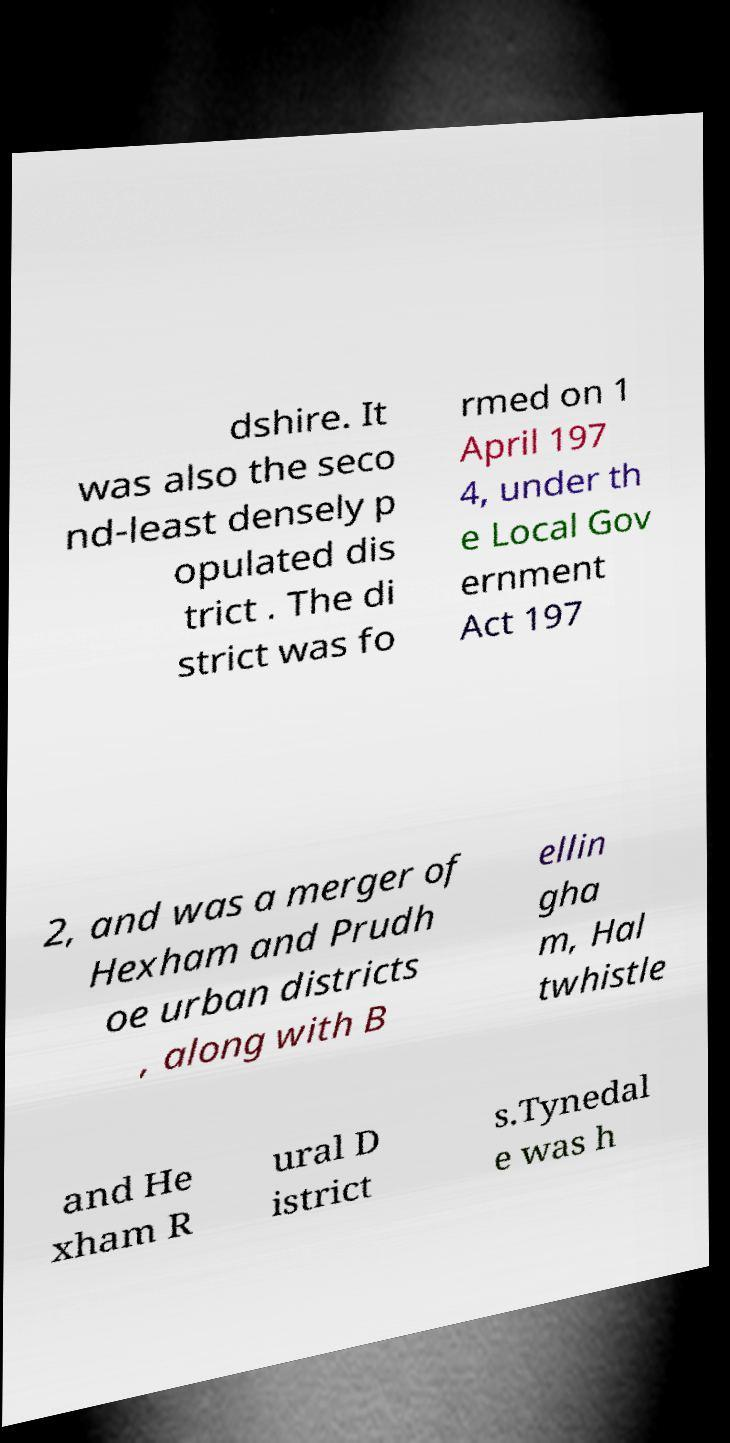What messages or text are displayed in this image? I need them in a readable, typed format. dshire. It was also the seco nd-least densely p opulated dis trict . The di strict was fo rmed on 1 April 197 4, under th e Local Gov ernment Act 197 2, and was a merger of Hexham and Prudh oe urban districts , along with B ellin gha m, Hal twhistle and He xham R ural D istrict s.Tynedal e was h 